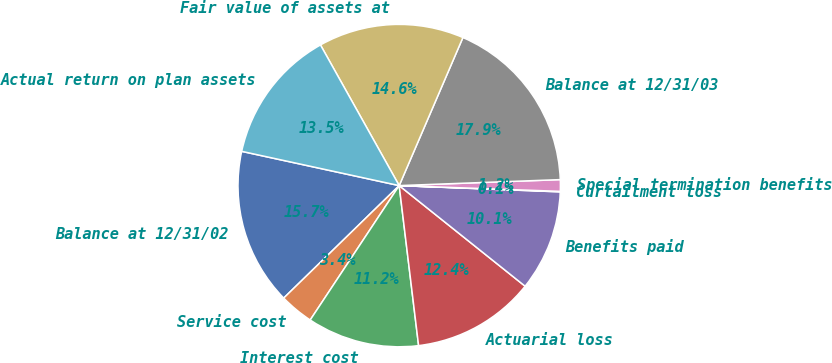Convert chart to OTSL. <chart><loc_0><loc_0><loc_500><loc_500><pie_chart><fcel>Balance at 12/31/02<fcel>Service cost<fcel>Interest cost<fcel>Actuarial loss<fcel>Benefits paid<fcel>Curtailment loss<fcel>Special termination benefits<fcel>Balance at 12/31/03<fcel>Fair value of assets at<fcel>Actual return on plan assets<nl><fcel>15.7%<fcel>3.4%<fcel>11.23%<fcel>12.35%<fcel>10.11%<fcel>0.05%<fcel>1.16%<fcel>17.94%<fcel>14.59%<fcel>13.47%<nl></chart> 